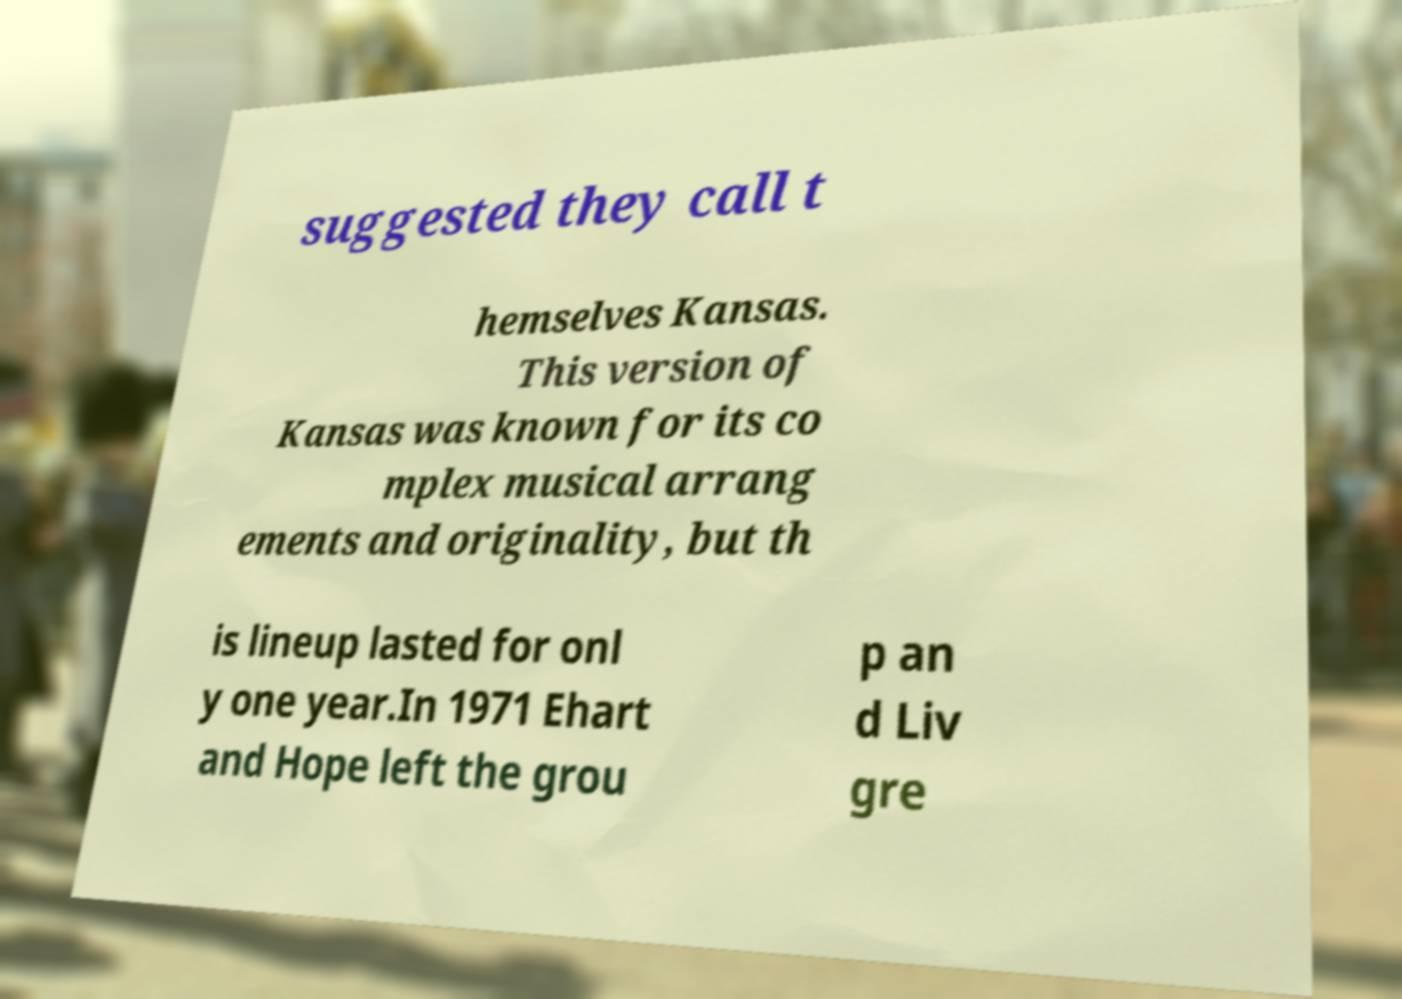Please read and relay the text visible in this image. What does it say? suggested they call t hemselves Kansas. This version of Kansas was known for its co mplex musical arrang ements and originality, but th is lineup lasted for onl y one year.In 1971 Ehart and Hope left the grou p an d Liv gre 